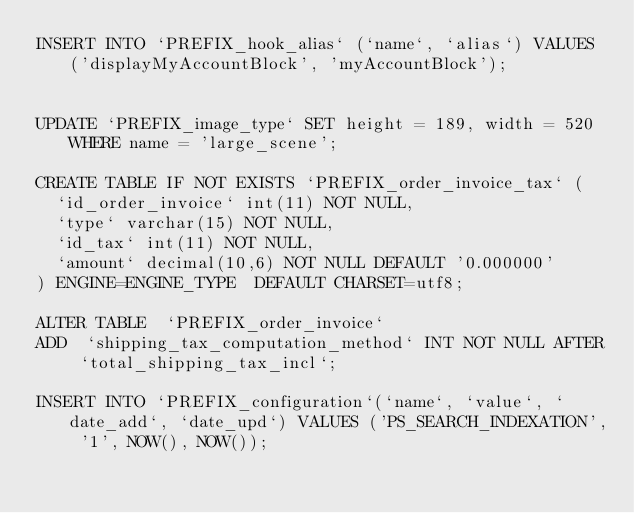Convert code to text. <code><loc_0><loc_0><loc_500><loc_500><_SQL_>INSERT INTO `PREFIX_hook_alias` (`name`, `alias`) VALUES ('displayMyAccountBlock', 'myAccountBlock');


UPDATE `PREFIX_image_type` SET height = 189, width = 520 WHERE name = 'large_scene';

CREATE TABLE IF NOT EXISTS `PREFIX_order_invoice_tax` (
  `id_order_invoice` int(11) NOT NULL,
  `type` varchar(15) NOT NULL,
  `id_tax` int(11) NOT NULL,
  `amount` decimal(10,6) NOT NULL DEFAULT '0.000000'
) ENGINE=ENGINE_TYPE  DEFAULT CHARSET=utf8;

ALTER TABLE  `PREFIX_order_invoice`
ADD  `shipping_tax_computation_method` INT NOT NULL AFTER `total_shipping_tax_incl`;

INSERT INTO `PREFIX_configuration`(`name`, `value`, `date_add`, `date_upd`) VALUES ('PS_SEARCH_INDEXATION', '1', NOW(), NOW());
</code> 